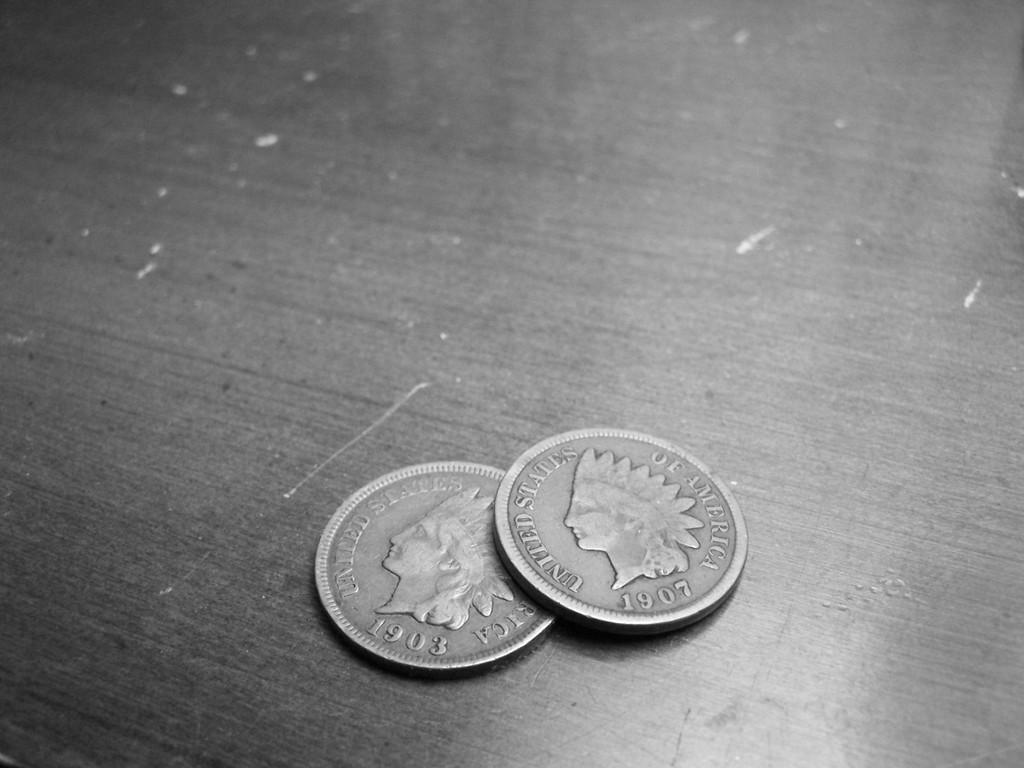What years are on the coins?
Your response must be concise. 1903 and 1907. What country are these coins from?
Offer a terse response. United states of america. 